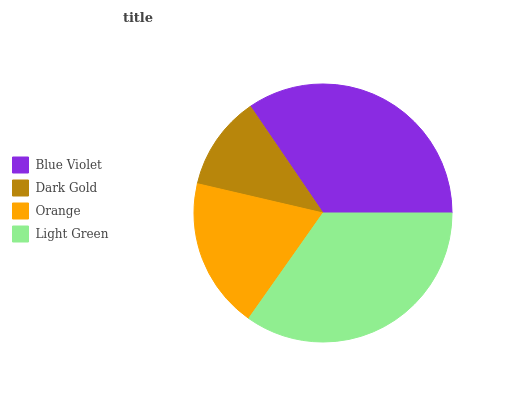Is Dark Gold the minimum?
Answer yes or no. Yes. Is Light Green the maximum?
Answer yes or no. Yes. Is Orange the minimum?
Answer yes or no. No. Is Orange the maximum?
Answer yes or no. No. Is Orange greater than Dark Gold?
Answer yes or no. Yes. Is Dark Gold less than Orange?
Answer yes or no. Yes. Is Dark Gold greater than Orange?
Answer yes or no. No. Is Orange less than Dark Gold?
Answer yes or no. No. Is Blue Violet the high median?
Answer yes or no. Yes. Is Orange the low median?
Answer yes or no. Yes. Is Dark Gold the high median?
Answer yes or no. No. Is Dark Gold the low median?
Answer yes or no. No. 